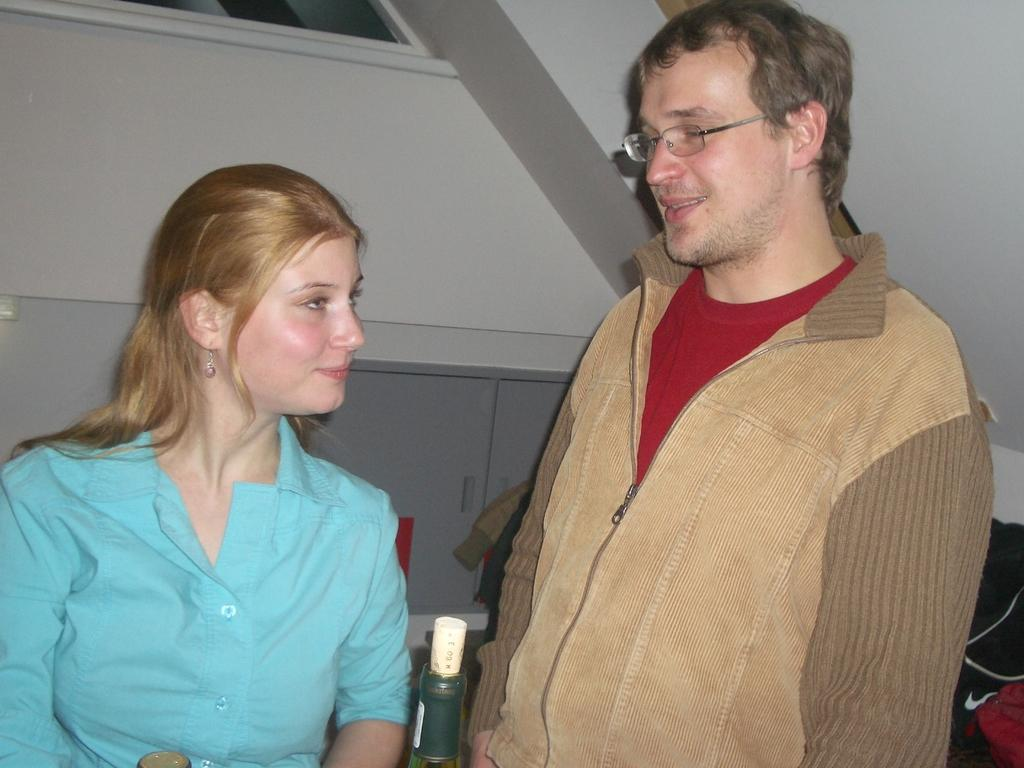What can be seen on the right side of the image? There is a man on the right side of the image. What can be seen on the left side of the image? There is a lady on the left side of the image. What is located at the top side of the image? There is a window at the top side of the image. What type of meal is being prepared by the girl in the image? There is no girl present in the image, and no meal preparation is depicted. 